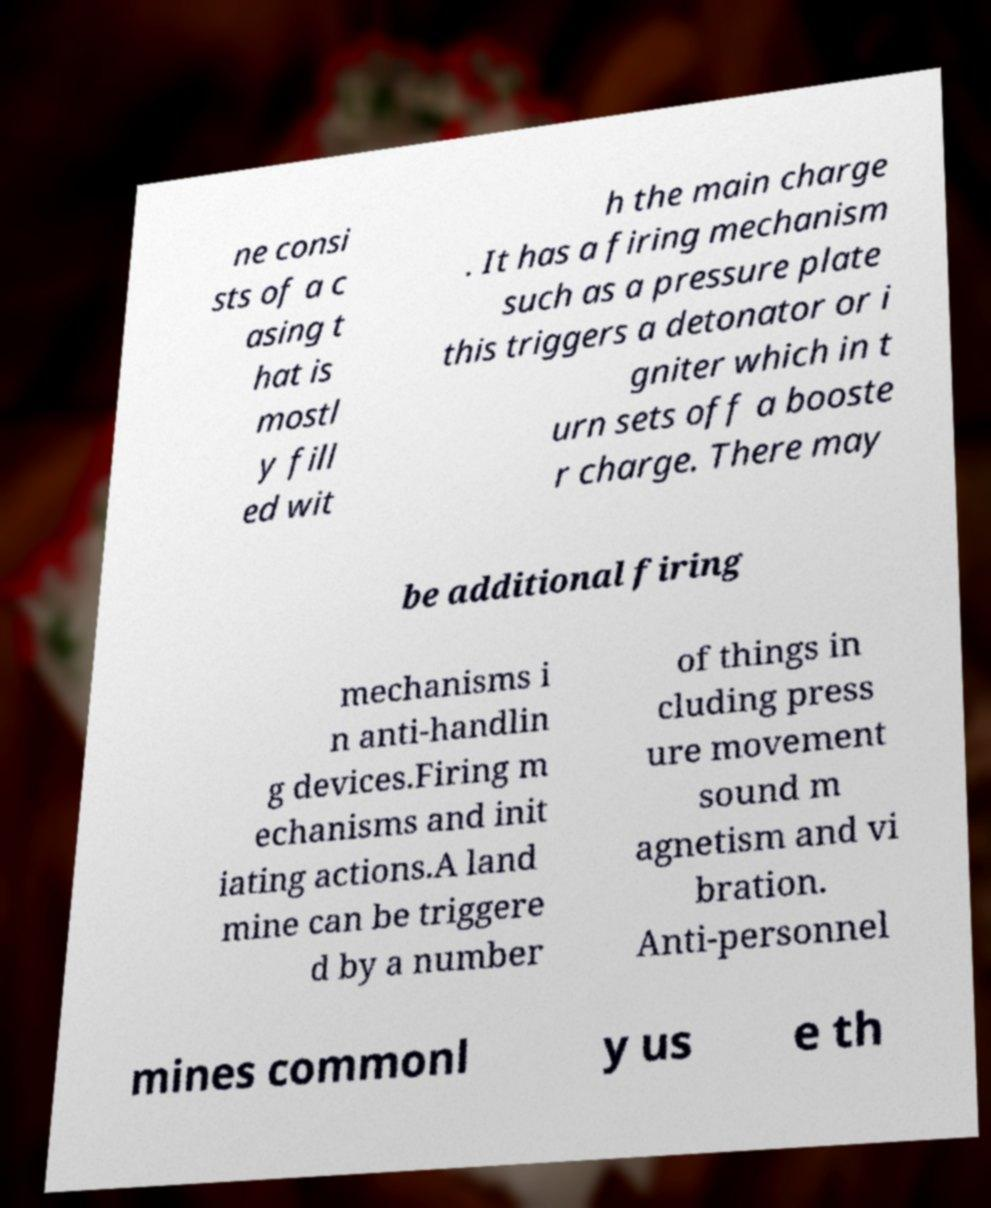There's text embedded in this image that I need extracted. Can you transcribe it verbatim? ne consi sts of a c asing t hat is mostl y fill ed wit h the main charge . It has a firing mechanism such as a pressure plate this triggers a detonator or i gniter which in t urn sets off a booste r charge. There may be additional firing mechanisms i n anti-handlin g devices.Firing m echanisms and init iating actions.A land mine can be triggere d by a number of things in cluding press ure movement sound m agnetism and vi bration. Anti-personnel mines commonl y us e th 